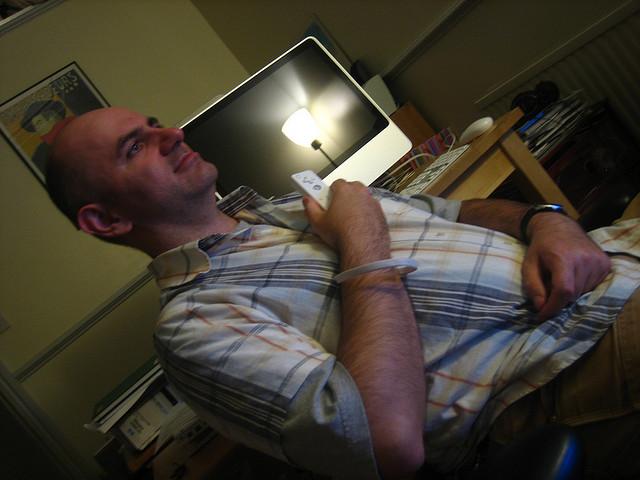What color is the man's shirt?
Answer briefly. White. Where is the man sitting at?
Answer briefly. Desk. What are the men doing?
Concise answer only. Playing wii. What program is on TV?
Give a very brief answer. None. What color is the person's shirt?
Be succinct. Plaid. What is the man holding?
Quick response, please. Wii remote. 